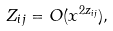Convert formula to latex. <formula><loc_0><loc_0><loc_500><loc_500>Z _ { i j } = O ( x ^ { 2 z _ { i j } } ) ,</formula> 